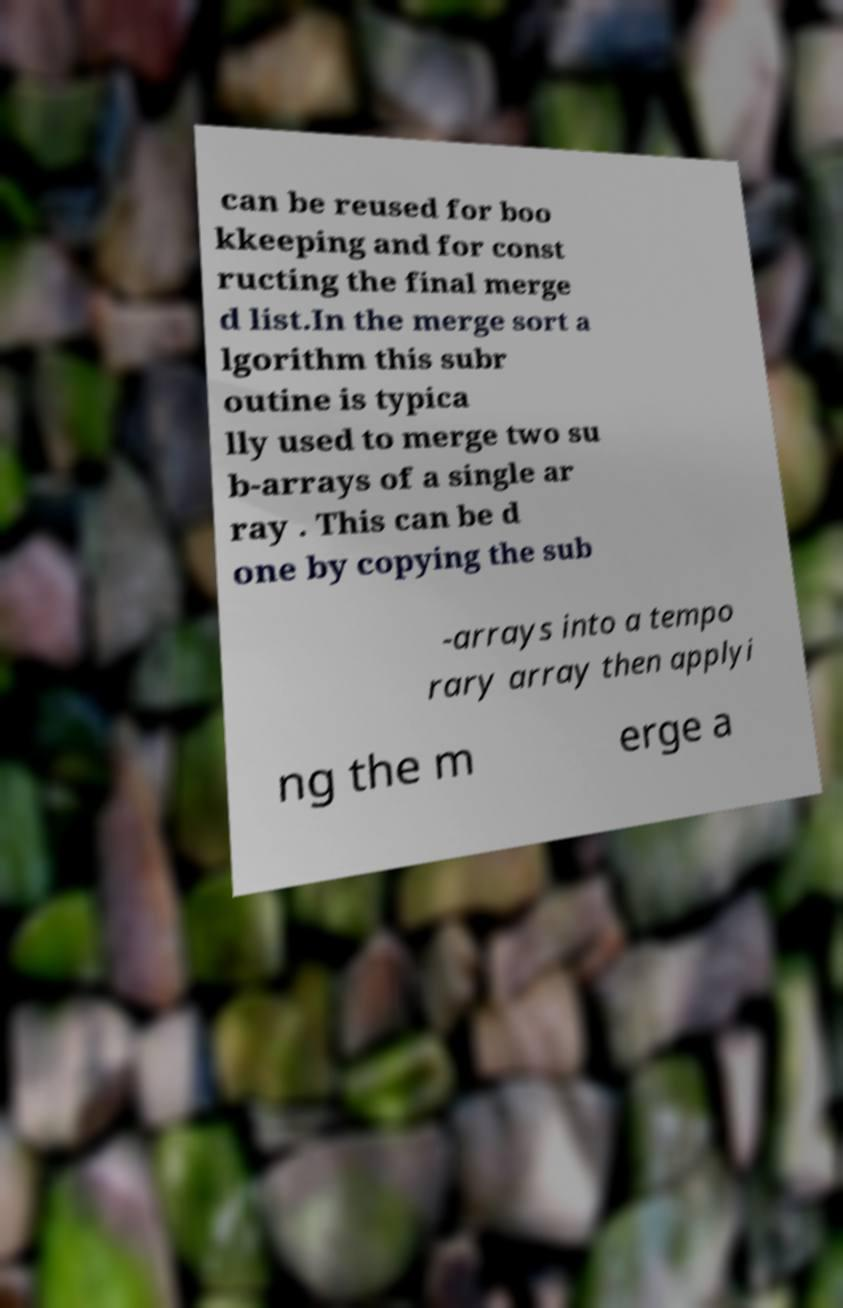Please read and relay the text visible in this image. What does it say? can be reused for boo kkeeping and for const ructing the final merge d list.In the merge sort a lgorithm this subr outine is typica lly used to merge two su b-arrays of a single ar ray . This can be d one by copying the sub -arrays into a tempo rary array then applyi ng the m erge a 